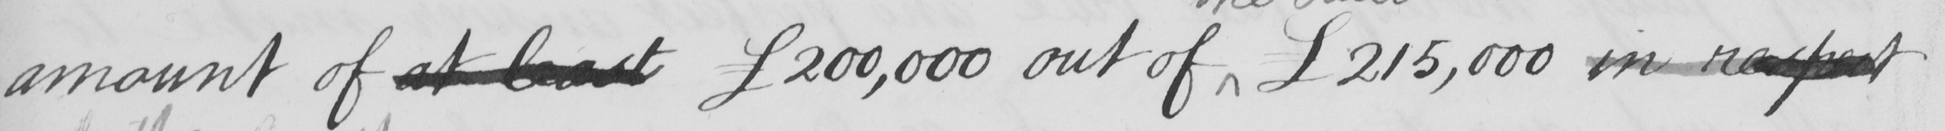What text is written in this handwritten line? amount of at least  £200,000 out of   £215,000 in respect 